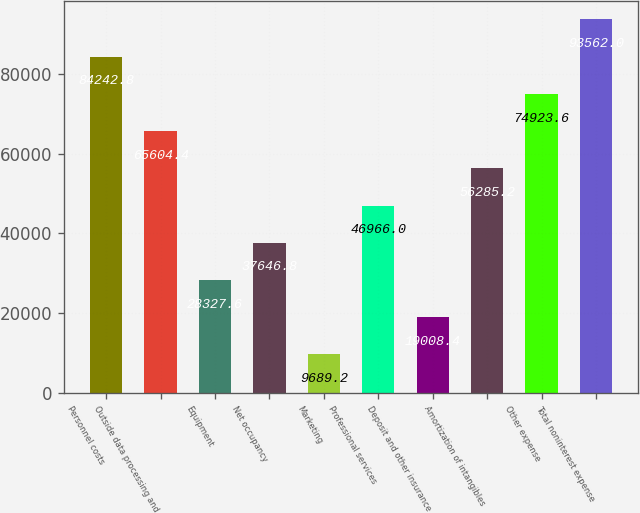Convert chart. <chart><loc_0><loc_0><loc_500><loc_500><bar_chart><fcel>Personnel costs<fcel>Outside data processing and<fcel>Equipment<fcel>Net occupancy<fcel>Marketing<fcel>Professional services<fcel>Deposit and other insurance<fcel>Amortization of intangibles<fcel>Other expense<fcel>Total noninterest expense<nl><fcel>84242.8<fcel>65604.4<fcel>28327.6<fcel>37646.8<fcel>9689.2<fcel>46966<fcel>19008.4<fcel>56285.2<fcel>74923.6<fcel>93562<nl></chart> 